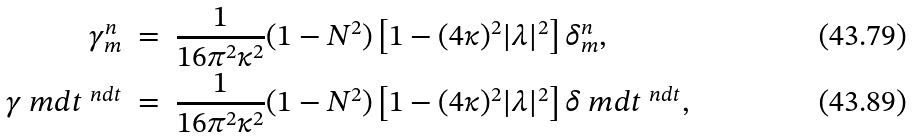<formula> <loc_0><loc_0><loc_500><loc_500>\gamma _ { m } ^ { n } \ & = \ \frac { 1 } { 1 6 \pi ^ { 2 } \kappa ^ { 2 } } ( 1 - N ^ { 2 } ) \left [ 1 - ( 4 \kappa ) ^ { 2 } | \lambda | ^ { 2 } \right ] \delta _ { m } ^ { n } , \\ \gamma _ { \ } m d t ^ { \ n d t } \ & = \ \frac { 1 } { 1 6 \pi ^ { 2 } \kappa ^ { 2 } } ( 1 - N ^ { 2 } ) \left [ 1 - ( 4 \kappa ) ^ { 2 } | \lambda | ^ { 2 } \right ] \delta _ { \ } m d t ^ { \ n d t } ,</formula> 